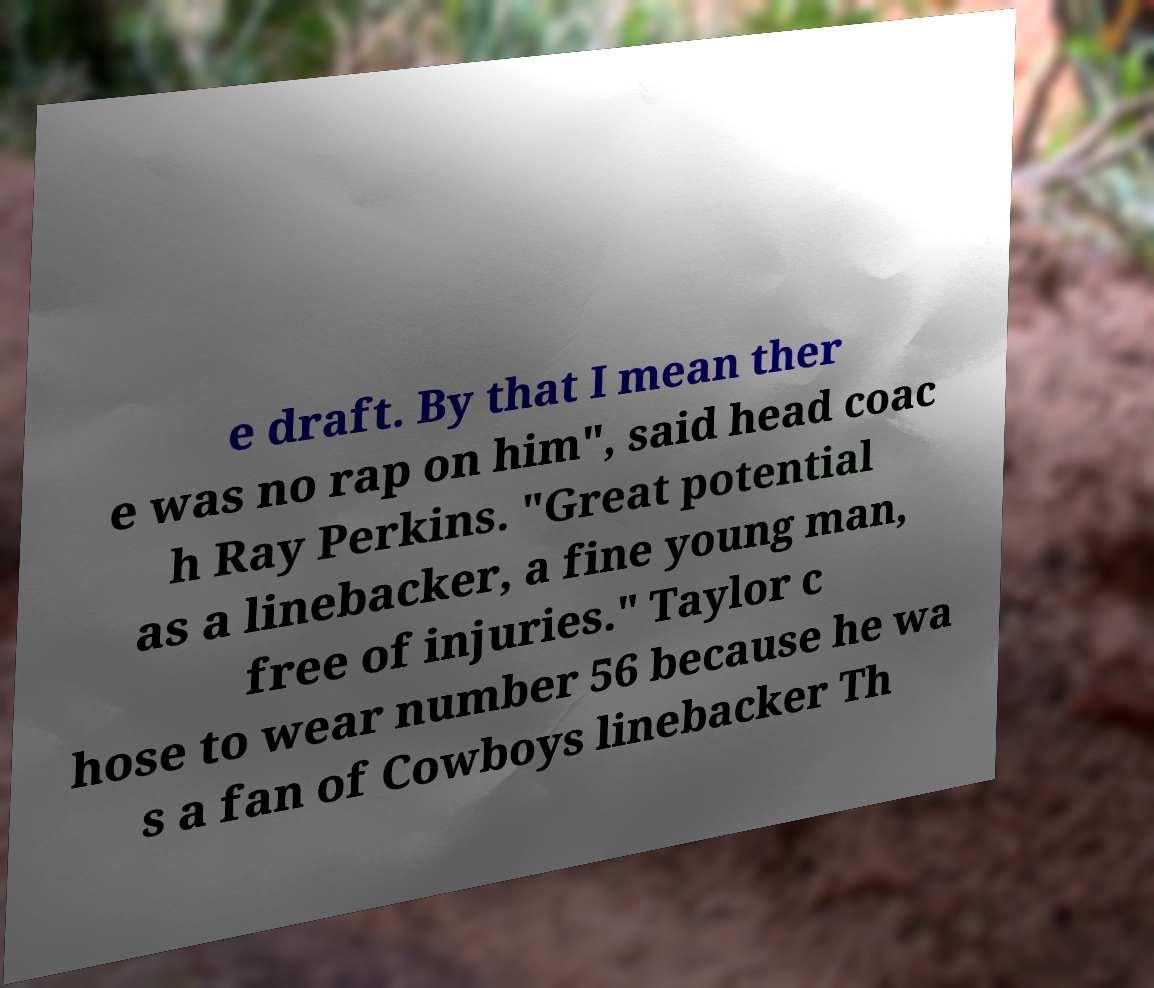I need the written content from this picture converted into text. Can you do that? e draft. By that I mean ther e was no rap on him", said head coac h Ray Perkins. "Great potential as a linebacker, a fine young man, free of injuries." Taylor c hose to wear number 56 because he wa s a fan of Cowboys linebacker Th 